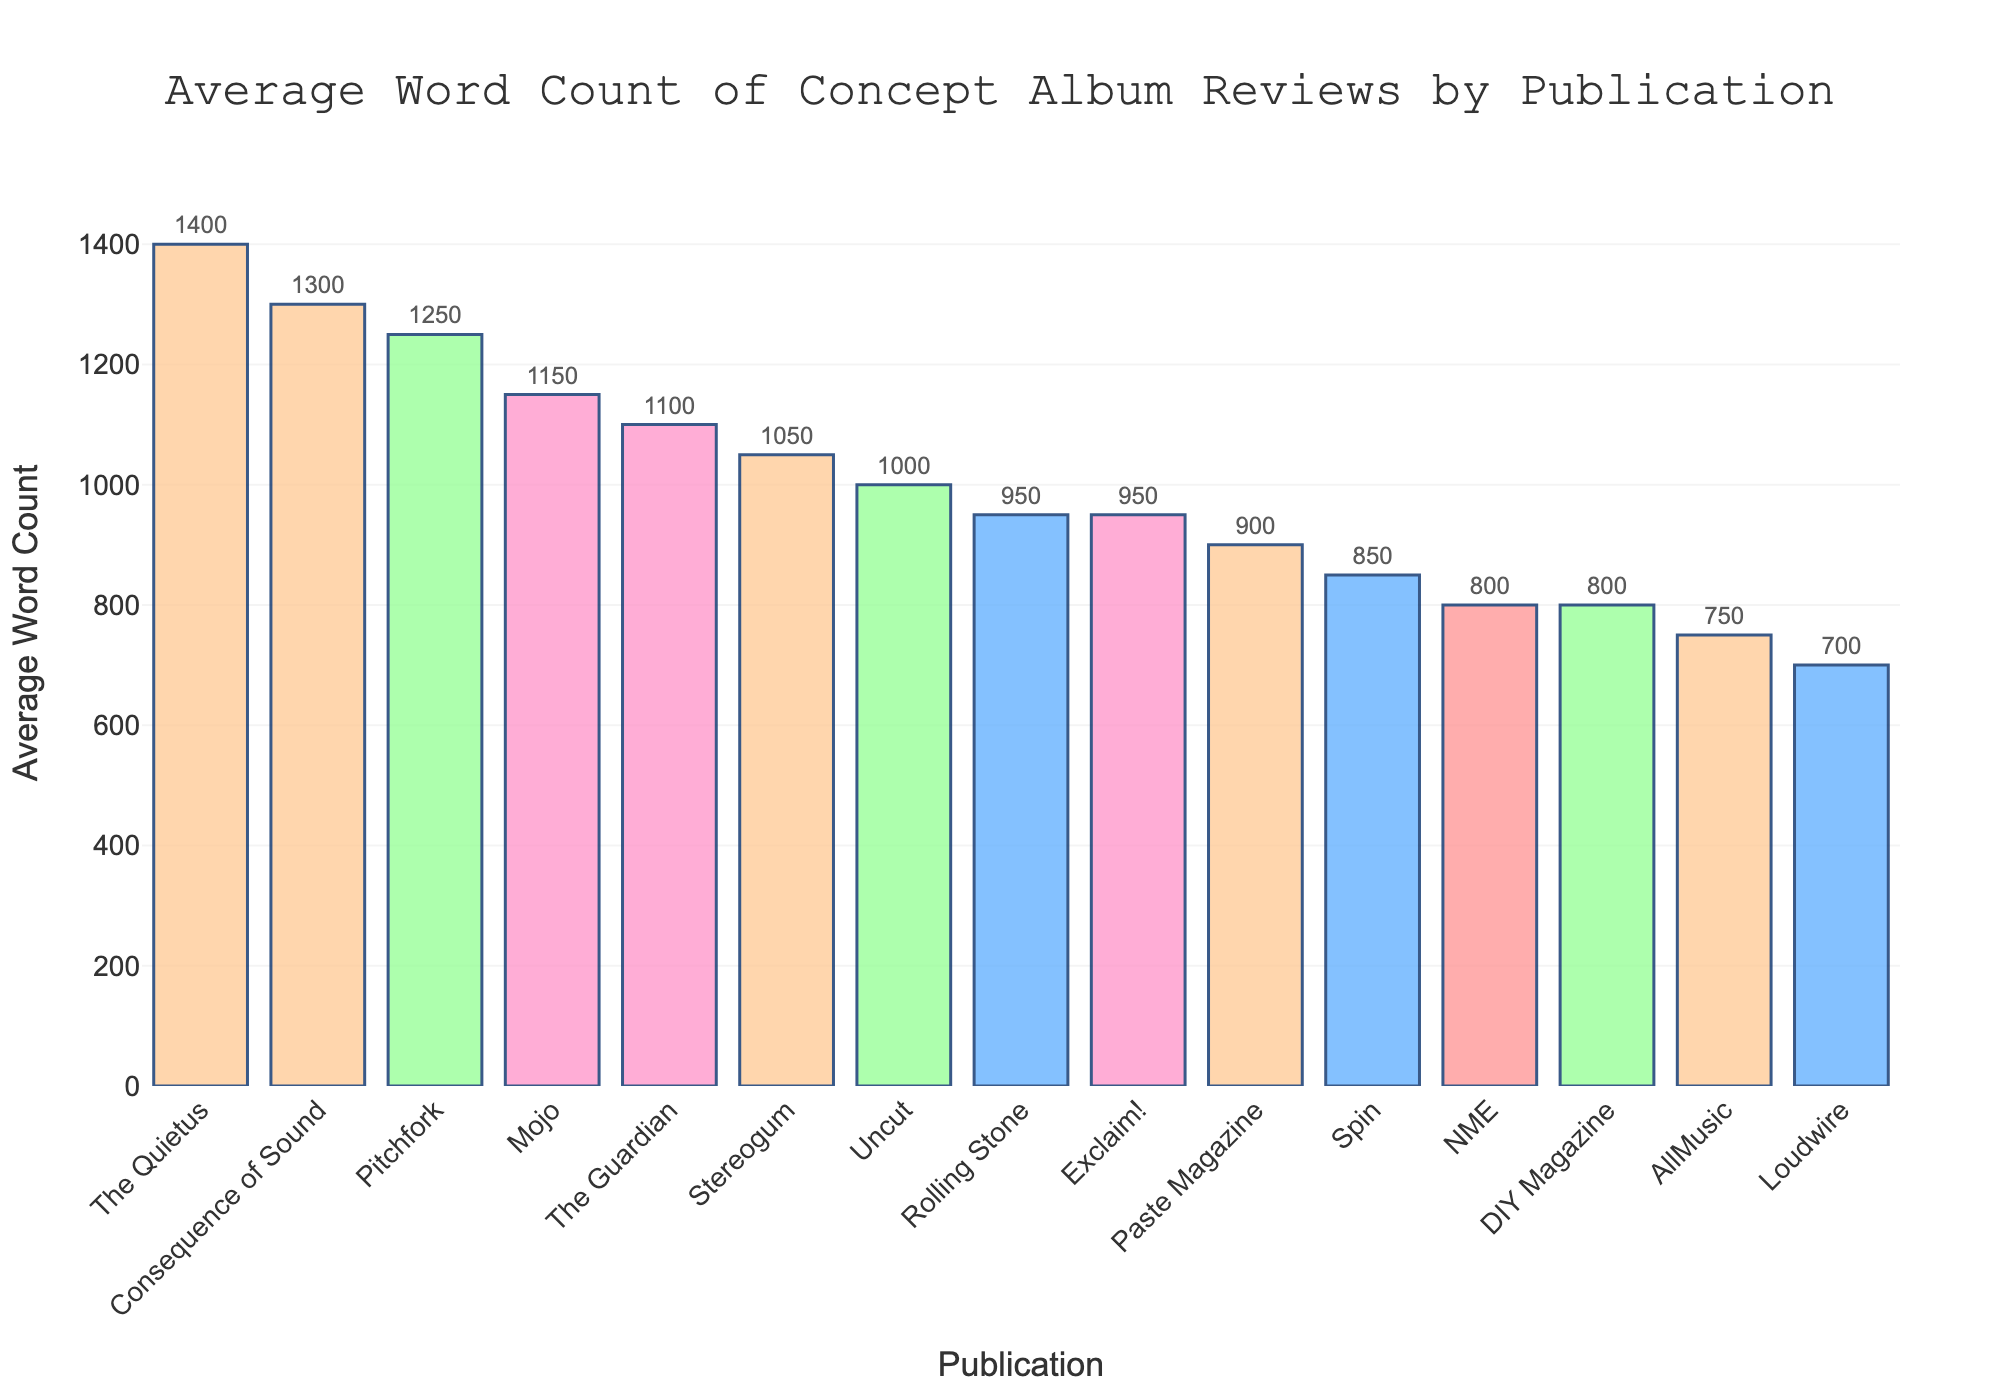What's the publication with the highest average word count? By looking at the bar chart, the publication with the tallest bar represents the highest average word count. The Quietus has the tallest bar.
Answer: The Quietus What's the difference in average word count between Pitchfork and Rolling Stone? Find the heights of Pitchfork's and Rolling Stone's bars. Pitchfork has 1250, and Rolling Stone has 950. The difference is 1250 - 950 = 300.
Answer: 300 Which publication has a higher average word count, NME or DIY Magazine? Compare the heights of the bars for NME and DIY Magazine. NME has an average word count of 800, and DIY Magazine also has 800. Neither is higher; they are equal.
Answer: They are equal What is the combined average word count of the top 3 publications? Identify the three publications with the tallest bars: The Quietus (1400), Consequence of Sound (1300), and Pitchfork (1250). Then sum their average word counts, 1400 + 1300 + 1250 = 3950.
Answer: 3950 Which has a lower average word count, Spin or Paste Magazine, and by how much? Look at the bars for Spin and Paste Magazine. Spin has 850, and Paste Magazine has 900. The difference is 900 - 850 = 50.
Answer: Spin by 50 What is the average word count for all the publications combined? Sum all the average word counts and divide by the number of publications. (1250 + 950 + 800 + 1100 + 1300 + 1050 + 750 + 900 + 850 + 700 + 1000 + 1150 + 1400 + 950 + 800) / 15 = 12350 / 15 = 823.33.
Answer: 823.33 How does the average word count of Paste Magazine compare to AllMusic? Paste Magazine has a word count of 900, and AllMusic has 750. Thus, Paste Magazine has a higher word count by 150.
Answer: Paste Magazine by 150 By how much does the average word count for Loudwire need to increase to match The Guardian? Loudwire's average word count is 700, while The Guardian's is 1100. The difference is 1100 - 700 = 400.
Answer: 400 Which publication has a near average (i.e., closest to) the overall average word count? The overall average word count is 823.33. Compare this to the individual publications' average word counts: 800 (NME), 850 (Spin). Spin is closer to 823.33.
Answer: Spin 